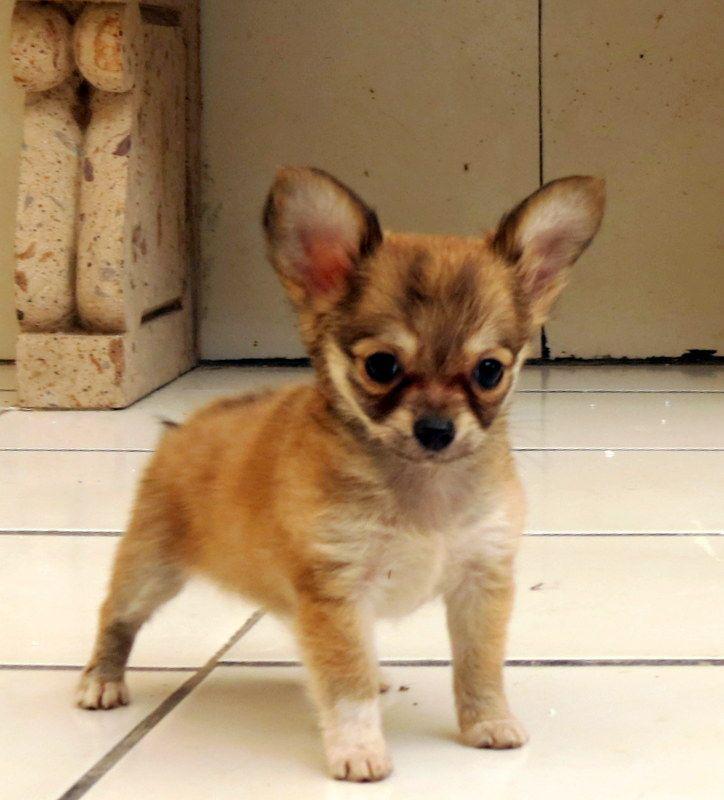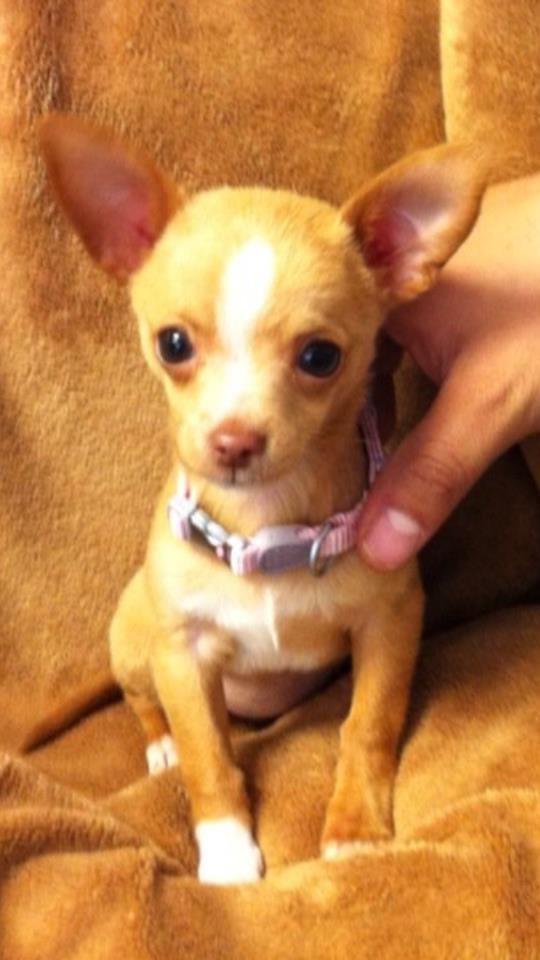The first image is the image on the left, the second image is the image on the right. Analyze the images presented: Is the assertion "One of the dogs is outside." valid? Answer yes or no. No. The first image is the image on the left, the second image is the image on the right. Analyze the images presented: Is the assertion "Each image includes just one dog." valid? Answer yes or no. Yes. 